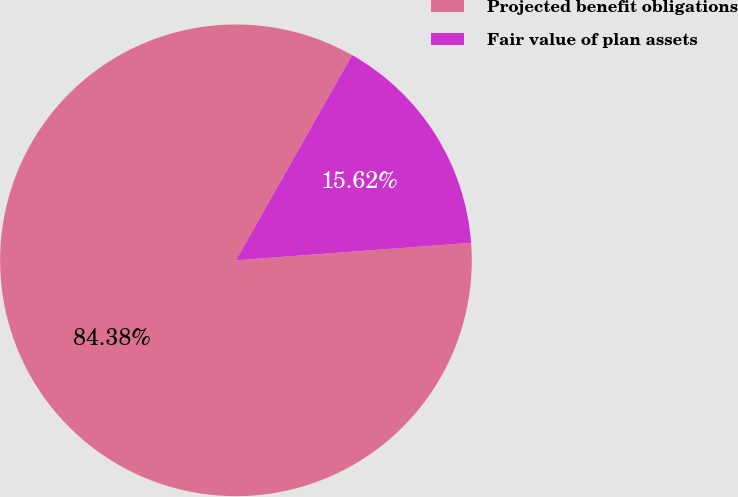<chart> <loc_0><loc_0><loc_500><loc_500><pie_chart><fcel>Projected benefit obligations<fcel>Fair value of plan assets<nl><fcel>84.38%<fcel>15.62%<nl></chart> 